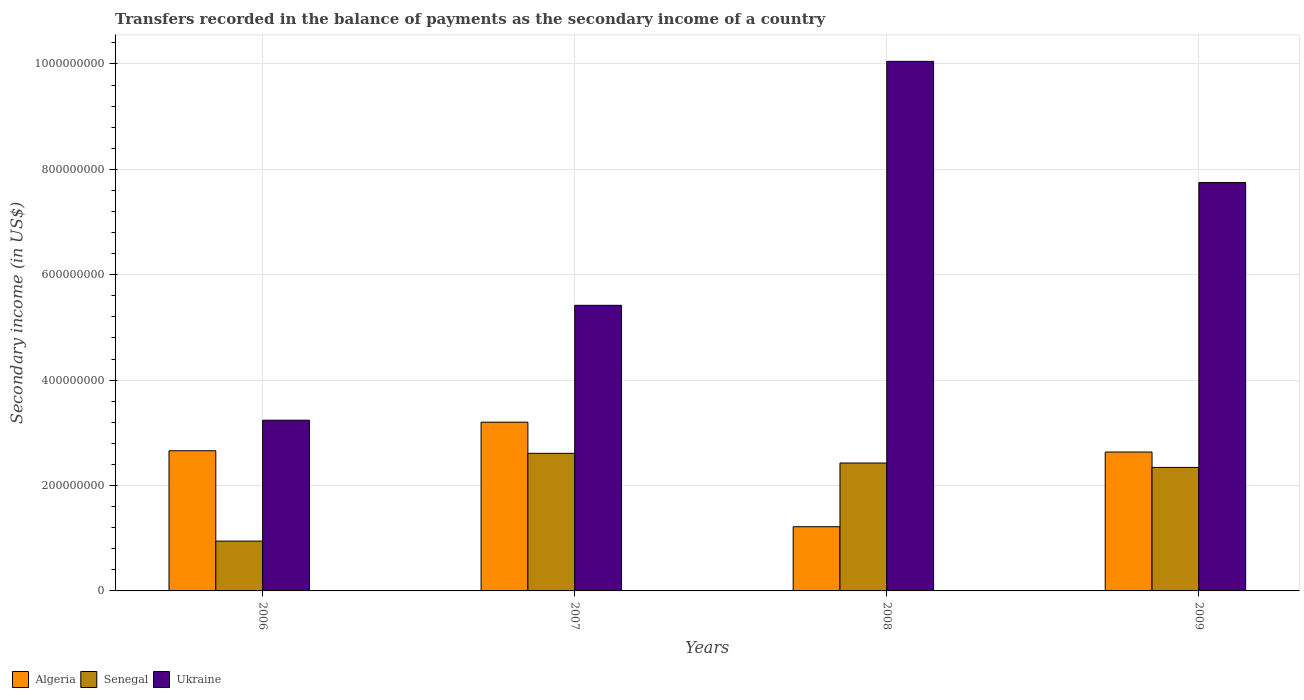How many different coloured bars are there?
Your answer should be compact. 3. Are the number of bars on each tick of the X-axis equal?
Your response must be concise. Yes. In how many cases, is the number of bars for a given year not equal to the number of legend labels?
Your answer should be compact. 0. What is the secondary income of in Algeria in 2008?
Provide a short and direct response. 1.22e+08. Across all years, what is the maximum secondary income of in Senegal?
Keep it short and to the point. 2.61e+08. Across all years, what is the minimum secondary income of in Algeria?
Offer a very short reply. 1.22e+08. In which year was the secondary income of in Senegal maximum?
Offer a terse response. 2007. In which year was the secondary income of in Senegal minimum?
Offer a very short reply. 2006. What is the total secondary income of in Ukraine in the graph?
Offer a very short reply. 2.65e+09. What is the difference between the secondary income of in Senegal in 2008 and that in 2009?
Ensure brevity in your answer.  8.34e+06. What is the difference between the secondary income of in Ukraine in 2009 and the secondary income of in Algeria in 2006?
Make the answer very short. 5.09e+08. What is the average secondary income of in Ukraine per year?
Make the answer very short. 6.62e+08. In the year 2006, what is the difference between the secondary income of in Senegal and secondary income of in Ukraine?
Keep it short and to the point. -2.29e+08. What is the ratio of the secondary income of in Senegal in 2006 to that in 2008?
Your answer should be very brief. 0.39. Is the secondary income of in Ukraine in 2007 less than that in 2009?
Your response must be concise. Yes. Is the difference between the secondary income of in Senegal in 2008 and 2009 greater than the difference between the secondary income of in Ukraine in 2008 and 2009?
Give a very brief answer. No. What is the difference between the highest and the second highest secondary income of in Ukraine?
Your answer should be very brief. 2.30e+08. What is the difference between the highest and the lowest secondary income of in Algeria?
Make the answer very short. 1.98e+08. Is the sum of the secondary income of in Algeria in 2006 and 2008 greater than the maximum secondary income of in Ukraine across all years?
Your response must be concise. No. What does the 2nd bar from the left in 2007 represents?
Offer a very short reply. Senegal. What does the 2nd bar from the right in 2006 represents?
Offer a very short reply. Senegal. Are all the bars in the graph horizontal?
Provide a succinct answer. No. How many years are there in the graph?
Provide a short and direct response. 4. Are the values on the major ticks of Y-axis written in scientific E-notation?
Give a very brief answer. No. How many legend labels are there?
Offer a very short reply. 3. How are the legend labels stacked?
Ensure brevity in your answer.  Horizontal. What is the title of the graph?
Your answer should be very brief. Transfers recorded in the balance of payments as the secondary income of a country. Does "Dominican Republic" appear as one of the legend labels in the graph?
Your answer should be compact. No. What is the label or title of the Y-axis?
Offer a terse response. Secondary income (in US$). What is the Secondary income (in US$) of Algeria in 2006?
Offer a terse response. 2.66e+08. What is the Secondary income (in US$) of Senegal in 2006?
Ensure brevity in your answer.  9.45e+07. What is the Secondary income (in US$) in Ukraine in 2006?
Your answer should be compact. 3.24e+08. What is the Secondary income (in US$) of Algeria in 2007?
Give a very brief answer. 3.20e+08. What is the Secondary income (in US$) in Senegal in 2007?
Your answer should be very brief. 2.61e+08. What is the Secondary income (in US$) of Ukraine in 2007?
Your answer should be compact. 5.42e+08. What is the Secondary income (in US$) in Algeria in 2008?
Provide a succinct answer. 1.22e+08. What is the Secondary income (in US$) in Senegal in 2008?
Ensure brevity in your answer.  2.43e+08. What is the Secondary income (in US$) of Ukraine in 2008?
Offer a very short reply. 1.00e+09. What is the Secondary income (in US$) of Algeria in 2009?
Provide a succinct answer. 2.64e+08. What is the Secondary income (in US$) of Senegal in 2009?
Offer a very short reply. 2.34e+08. What is the Secondary income (in US$) in Ukraine in 2009?
Your answer should be compact. 7.75e+08. Across all years, what is the maximum Secondary income (in US$) of Algeria?
Your answer should be compact. 3.20e+08. Across all years, what is the maximum Secondary income (in US$) in Senegal?
Make the answer very short. 2.61e+08. Across all years, what is the maximum Secondary income (in US$) of Ukraine?
Provide a short and direct response. 1.00e+09. Across all years, what is the minimum Secondary income (in US$) in Algeria?
Your answer should be compact. 1.22e+08. Across all years, what is the minimum Secondary income (in US$) of Senegal?
Make the answer very short. 9.45e+07. Across all years, what is the minimum Secondary income (in US$) of Ukraine?
Give a very brief answer. 3.24e+08. What is the total Secondary income (in US$) in Algeria in the graph?
Make the answer very short. 9.72e+08. What is the total Secondary income (in US$) of Senegal in the graph?
Offer a very short reply. 8.33e+08. What is the total Secondary income (in US$) of Ukraine in the graph?
Make the answer very short. 2.65e+09. What is the difference between the Secondary income (in US$) of Algeria in 2006 and that in 2007?
Make the answer very short. -5.42e+07. What is the difference between the Secondary income (in US$) of Senegal in 2006 and that in 2007?
Provide a succinct answer. -1.67e+08. What is the difference between the Secondary income (in US$) in Ukraine in 2006 and that in 2007?
Your answer should be very brief. -2.18e+08. What is the difference between the Secondary income (in US$) of Algeria in 2006 and that in 2008?
Ensure brevity in your answer.  1.44e+08. What is the difference between the Secondary income (in US$) in Senegal in 2006 and that in 2008?
Your answer should be compact. -1.48e+08. What is the difference between the Secondary income (in US$) of Ukraine in 2006 and that in 2008?
Your answer should be compact. -6.81e+08. What is the difference between the Secondary income (in US$) in Algeria in 2006 and that in 2009?
Provide a short and direct response. 2.41e+06. What is the difference between the Secondary income (in US$) in Senegal in 2006 and that in 2009?
Ensure brevity in your answer.  -1.40e+08. What is the difference between the Secondary income (in US$) of Ukraine in 2006 and that in 2009?
Your answer should be compact. -4.51e+08. What is the difference between the Secondary income (in US$) of Algeria in 2007 and that in 2008?
Your answer should be very brief. 1.98e+08. What is the difference between the Secondary income (in US$) in Senegal in 2007 and that in 2008?
Offer a terse response. 1.84e+07. What is the difference between the Secondary income (in US$) in Ukraine in 2007 and that in 2008?
Ensure brevity in your answer.  -4.63e+08. What is the difference between the Secondary income (in US$) in Algeria in 2007 and that in 2009?
Offer a very short reply. 5.67e+07. What is the difference between the Secondary income (in US$) of Senegal in 2007 and that in 2009?
Your answer should be compact. 2.67e+07. What is the difference between the Secondary income (in US$) of Ukraine in 2007 and that in 2009?
Keep it short and to the point. -2.33e+08. What is the difference between the Secondary income (in US$) in Algeria in 2008 and that in 2009?
Provide a succinct answer. -1.42e+08. What is the difference between the Secondary income (in US$) of Senegal in 2008 and that in 2009?
Make the answer very short. 8.34e+06. What is the difference between the Secondary income (in US$) in Ukraine in 2008 and that in 2009?
Give a very brief answer. 2.30e+08. What is the difference between the Secondary income (in US$) of Algeria in 2006 and the Secondary income (in US$) of Senegal in 2007?
Keep it short and to the point. 4.87e+06. What is the difference between the Secondary income (in US$) of Algeria in 2006 and the Secondary income (in US$) of Ukraine in 2007?
Your response must be concise. -2.76e+08. What is the difference between the Secondary income (in US$) in Senegal in 2006 and the Secondary income (in US$) in Ukraine in 2007?
Keep it short and to the point. -4.47e+08. What is the difference between the Secondary income (in US$) in Algeria in 2006 and the Secondary income (in US$) in Senegal in 2008?
Your response must be concise. 2.33e+07. What is the difference between the Secondary income (in US$) in Algeria in 2006 and the Secondary income (in US$) in Ukraine in 2008?
Keep it short and to the point. -7.39e+08. What is the difference between the Secondary income (in US$) of Senegal in 2006 and the Secondary income (in US$) of Ukraine in 2008?
Ensure brevity in your answer.  -9.10e+08. What is the difference between the Secondary income (in US$) in Algeria in 2006 and the Secondary income (in US$) in Senegal in 2009?
Provide a short and direct response. 3.16e+07. What is the difference between the Secondary income (in US$) in Algeria in 2006 and the Secondary income (in US$) in Ukraine in 2009?
Provide a short and direct response. -5.09e+08. What is the difference between the Secondary income (in US$) in Senegal in 2006 and the Secondary income (in US$) in Ukraine in 2009?
Your answer should be very brief. -6.80e+08. What is the difference between the Secondary income (in US$) in Algeria in 2007 and the Secondary income (in US$) in Senegal in 2008?
Provide a short and direct response. 7.75e+07. What is the difference between the Secondary income (in US$) in Algeria in 2007 and the Secondary income (in US$) in Ukraine in 2008?
Ensure brevity in your answer.  -6.85e+08. What is the difference between the Secondary income (in US$) of Senegal in 2007 and the Secondary income (in US$) of Ukraine in 2008?
Provide a succinct answer. -7.44e+08. What is the difference between the Secondary income (in US$) in Algeria in 2007 and the Secondary income (in US$) in Senegal in 2009?
Make the answer very short. 8.58e+07. What is the difference between the Secondary income (in US$) of Algeria in 2007 and the Secondary income (in US$) of Ukraine in 2009?
Give a very brief answer. -4.55e+08. What is the difference between the Secondary income (in US$) of Senegal in 2007 and the Secondary income (in US$) of Ukraine in 2009?
Ensure brevity in your answer.  -5.14e+08. What is the difference between the Secondary income (in US$) of Algeria in 2008 and the Secondary income (in US$) of Senegal in 2009?
Your answer should be very brief. -1.13e+08. What is the difference between the Secondary income (in US$) of Algeria in 2008 and the Secondary income (in US$) of Ukraine in 2009?
Offer a very short reply. -6.53e+08. What is the difference between the Secondary income (in US$) of Senegal in 2008 and the Secondary income (in US$) of Ukraine in 2009?
Provide a short and direct response. -5.32e+08. What is the average Secondary income (in US$) in Algeria per year?
Give a very brief answer. 2.43e+08. What is the average Secondary income (in US$) of Senegal per year?
Ensure brevity in your answer.  2.08e+08. What is the average Secondary income (in US$) of Ukraine per year?
Provide a succinct answer. 6.62e+08. In the year 2006, what is the difference between the Secondary income (in US$) in Algeria and Secondary income (in US$) in Senegal?
Offer a terse response. 1.71e+08. In the year 2006, what is the difference between the Secondary income (in US$) in Algeria and Secondary income (in US$) in Ukraine?
Your response must be concise. -5.80e+07. In the year 2006, what is the difference between the Secondary income (in US$) of Senegal and Secondary income (in US$) of Ukraine?
Your answer should be compact. -2.29e+08. In the year 2007, what is the difference between the Secondary income (in US$) in Algeria and Secondary income (in US$) in Senegal?
Offer a terse response. 5.91e+07. In the year 2007, what is the difference between the Secondary income (in US$) in Algeria and Secondary income (in US$) in Ukraine?
Your answer should be compact. -2.22e+08. In the year 2007, what is the difference between the Secondary income (in US$) in Senegal and Secondary income (in US$) in Ukraine?
Your answer should be very brief. -2.81e+08. In the year 2008, what is the difference between the Secondary income (in US$) in Algeria and Secondary income (in US$) in Senegal?
Your response must be concise. -1.21e+08. In the year 2008, what is the difference between the Secondary income (in US$) of Algeria and Secondary income (in US$) of Ukraine?
Offer a very short reply. -8.83e+08. In the year 2008, what is the difference between the Secondary income (in US$) in Senegal and Secondary income (in US$) in Ukraine?
Provide a short and direct response. -7.62e+08. In the year 2009, what is the difference between the Secondary income (in US$) in Algeria and Secondary income (in US$) in Senegal?
Give a very brief answer. 2.92e+07. In the year 2009, what is the difference between the Secondary income (in US$) in Algeria and Secondary income (in US$) in Ukraine?
Offer a very short reply. -5.11e+08. In the year 2009, what is the difference between the Secondary income (in US$) of Senegal and Secondary income (in US$) of Ukraine?
Make the answer very short. -5.41e+08. What is the ratio of the Secondary income (in US$) in Algeria in 2006 to that in 2007?
Your answer should be very brief. 0.83. What is the ratio of the Secondary income (in US$) of Senegal in 2006 to that in 2007?
Your answer should be compact. 0.36. What is the ratio of the Secondary income (in US$) of Ukraine in 2006 to that in 2007?
Give a very brief answer. 0.6. What is the ratio of the Secondary income (in US$) in Algeria in 2006 to that in 2008?
Give a very brief answer. 2.18. What is the ratio of the Secondary income (in US$) in Senegal in 2006 to that in 2008?
Your answer should be very brief. 0.39. What is the ratio of the Secondary income (in US$) in Ukraine in 2006 to that in 2008?
Offer a very short reply. 0.32. What is the ratio of the Secondary income (in US$) in Algeria in 2006 to that in 2009?
Your answer should be compact. 1.01. What is the ratio of the Secondary income (in US$) in Senegal in 2006 to that in 2009?
Your response must be concise. 0.4. What is the ratio of the Secondary income (in US$) in Ukraine in 2006 to that in 2009?
Provide a short and direct response. 0.42. What is the ratio of the Secondary income (in US$) of Algeria in 2007 to that in 2008?
Keep it short and to the point. 2.63. What is the ratio of the Secondary income (in US$) of Senegal in 2007 to that in 2008?
Offer a very short reply. 1.08. What is the ratio of the Secondary income (in US$) of Ukraine in 2007 to that in 2008?
Ensure brevity in your answer.  0.54. What is the ratio of the Secondary income (in US$) of Algeria in 2007 to that in 2009?
Give a very brief answer. 1.21. What is the ratio of the Secondary income (in US$) in Senegal in 2007 to that in 2009?
Provide a succinct answer. 1.11. What is the ratio of the Secondary income (in US$) of Ukraine in 2007 to that in 2009?
Provide a short and direct response. 0.7. What is the ratio of the Secondary income (in US$) of Algeria in 2008 to that in 2009?
Provide a succinct answer. 0.46. What is the ratio of the Secondary income (in US$) in Senegal in 2008 to that in 2009?
Offer a very short reply. 1.04. What is the ratio of the Secondary income (in US$) in Ukraine in 2008 to that in 2009?
Your response must be concise. 1.3. What is the difference between the highest and the second highest Secondary income (in US$) of Algeria?
Provide a short and direct response. 5.42e+07. What is the difference between the highest and the second highest Secondary income (in US$) in Senegal?
Provide a short and direct response. 1.84e+07. What is the difference between the highest and the second highest Secondary income (in US$) of Ukraine?
Provide a short and direct response. 2.30e+08. What is the difference between the highest and the lowest Secondary income (in US$) in Algeria?
Your answer should be compact. 1.98e+08. What is the difference between the highest and the lowest Secondary income (in US$) of Senegal?
Offer a very short reply. 1.67e+08. What is the difference between the highest and the lowest Secondary income (in US$) of Ukraine?
Ensure brevity in your answer.  6.81e+08. 